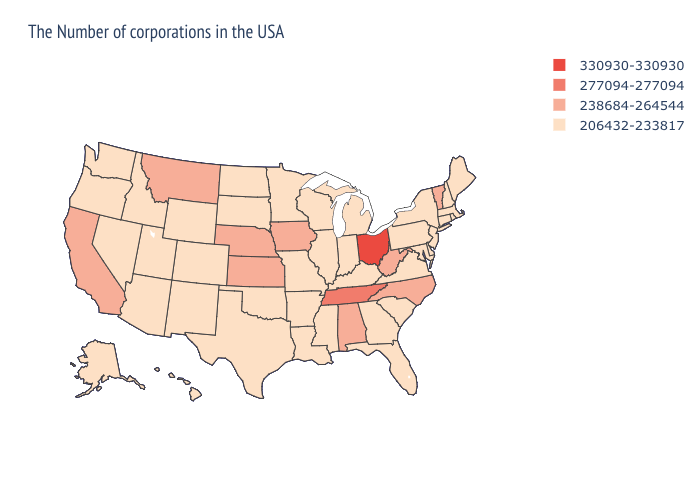Among the states that border Missouri , which have the highest value?
Concise answer only. Tennessee. Name the states that have a value in the range 238684-264544?
Answer briefly. Vermont, North Carolina, West Virginia, Alabama, Iowa, Kansas, Nebraska, Montana, California. Does Florida have the same value as Ohio?
Quick response, please. No. What is the value of Iowa?
Short answer required. 238684-264544. What is the value of West Virginia?
Quick response, please. 238684-264544. What is the value of Idaho?
Write a very short answer. 206432-233817. Does Texas have a lower value than Alaska?
Write a very short answer. No. Which states have the lowest value in the USA?
Quick response, please. Maine, Massachusetts, Rhode Island, New Hampshire, Connecticut, New York, New Jersey, Delaware, Maryland, Pennsylvania, Virginia, South Carolina, Florida, Georgia, Michigan, Kentucky, Indiana, Wisconsin, Illinois, Mississippi, Louisiana, Missouri, Arkansas, Minnesota, Oklahoma, Texas, South Dakota, North Dakota, Wyoming, Colorado, New Mexico, Utah, Arizona, Idaho, Nevada, Washington, Oregon, Alaska, Hawaii. Name the states that have a value in the range 277094-277094?
Short answer required. Tennessee. Does West Virginia have the lowest value in the South?
Answer briefly. No. Is the legend a continuous bar?
Be succinct. No. Does New York have the lowest value in the USA?
Answer briefly. Yes. What is the value of Kentucky?
Concise answer only. 206432-233817. Which states have the lowest value in the USA?
Concise answer only. Maine, Massachusetts, Rhode Island, New Hampshire, Connecticut, New York, New Jersey, Delaware, Maryland, Pennsylvania, Virginia, South Carolina, Florida, Georgia, Michigan, Kentucky, Indiana, Wisconsin, Illinois, Mississippi, Louisiana, Missouri, Arkansas, Minnesota, Oklahoma, Texas, South Dakota, North Dakota, Wyoming, Colorado, New Mexico, Utah, Arizona, Idaho, Nevada, Washington, Oregon, Alaska, Hawaii. What is the value of Maine?
Quick response, please. 206432-233817. 